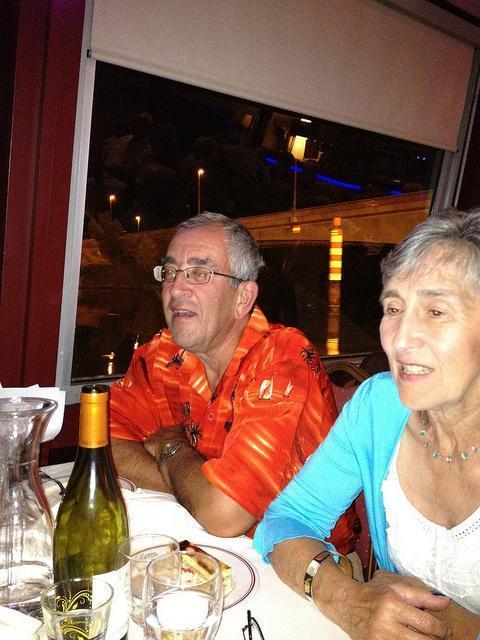Is the caption "The boat is around the dining table." a true representation of the image?
Answer yes or no. Yes. Does the description: "The dining table is enclosed by the boat." accurately reflect the image?
Answer yes or no. Yes. Is this affirmation: "The boat is in front of the dining table." correct?
Answer yes or no. No. Does the caption "The boat contains the dining table." correctly depict the image?
Answer yes or no. Yes. 